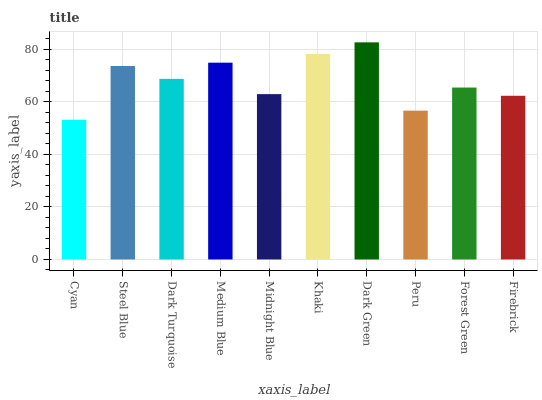Is Cyan the minimum?
Answer yes or no. Yes. Is Dark Green the maximum?
Answer yes or no. Yes. Is Steel Blue the minimum?
Answer yes or no. No. Is Steel Blue the maximum?
Answer yes or no. No. Is Steel Blue greater than Cyan?
Answer yes or no. Yes. Is Cyan less than Steel Blue?
Answer yes or no. Yes. Is Cyan greater than Steel Blue?
Answer yes or no. No. Is Steel Blue less than Cyan?
Answer yes or no. No. Is Dark Turquoise the high median?
Answer yes or no. Yes. Is Forest Green the low median?
Answer yes or no. Yes. Is Steel Blue the high median?
Answer yes or no. No. Is Peru the low median?
Answer yes or no. No. 